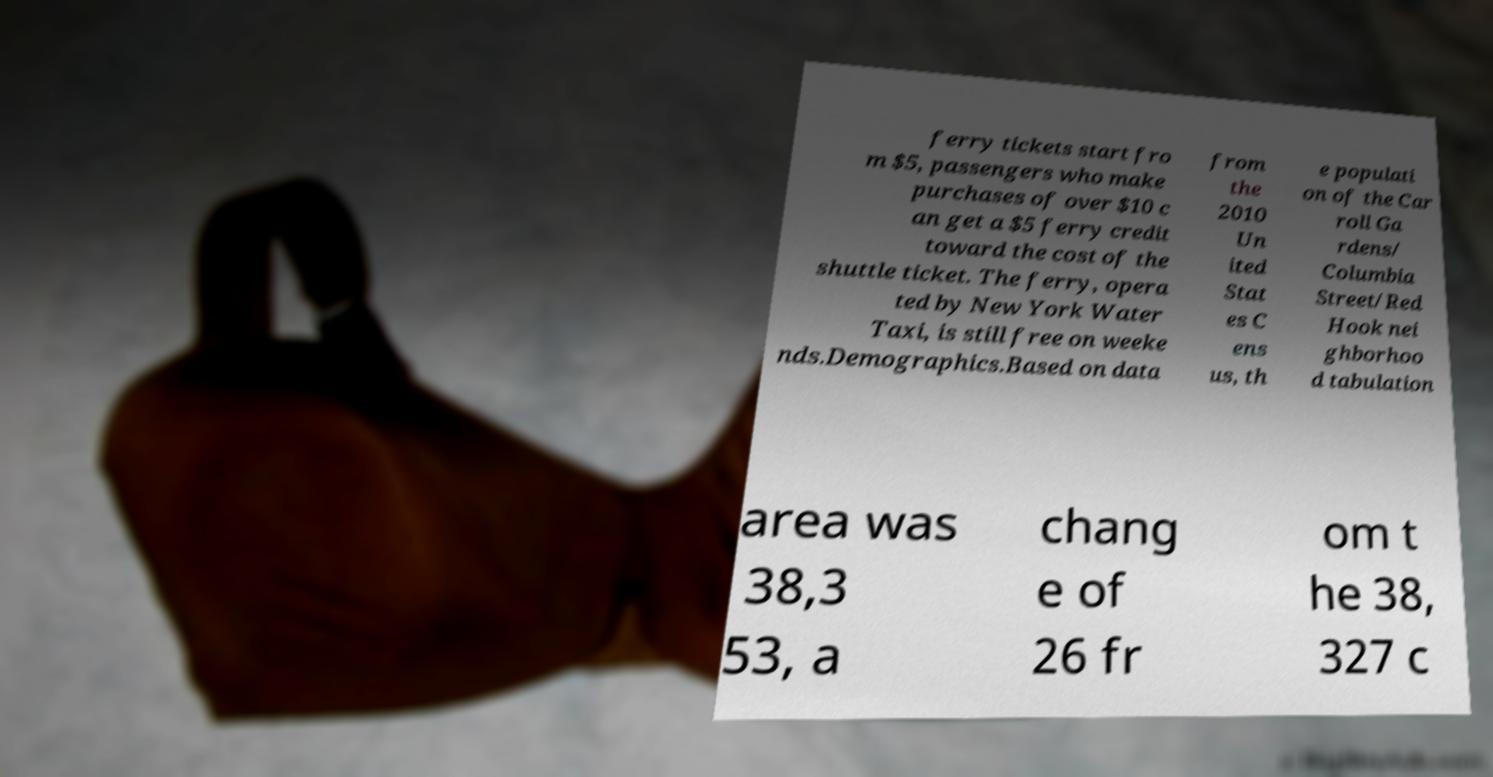Could you assist in decoding the text presented in this image and type it out clearly? ferry tickets start fro m $5, passengers who make purchases of over $10 c an get a $5 ferry credit toward the cost of the shuttle ticket. The ferry, opera ted by New York Water Taxi, is still free on weeke nds.Demographics.Based on data from the 2010 Un ited Stat es C ens us, th e populati on of the Car roll Ga rdens/ Columbia Street/Red Hook nei ghborhoo d tabulation area was 38,3 53, a chang e of 26 fr om t he 38, 327 c 